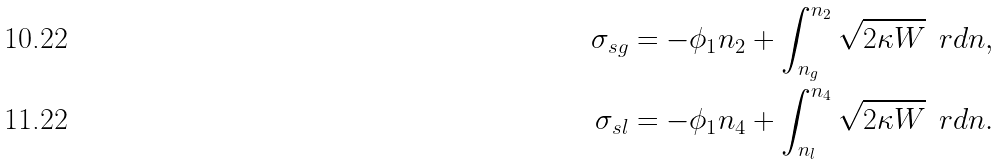Convert formula to latex. <formula><loc_0><loc_0><loc_500><loc_500>\sigma _ { s g } = - \phi _ { 1 } n _ { 2 } + \int _ { n _ { g } } ^ { n _ { 2 } } \sqrt { 2 \kappa W } \, \ r d n , \\ \sigma _ { s l } = - \phi _ { 1 } n _ { 4 } + \int _ { n _ { l } } ^ { n _ { 4 } } \sqrt { 2 \kappa W } \, \ r d n .</formula> 